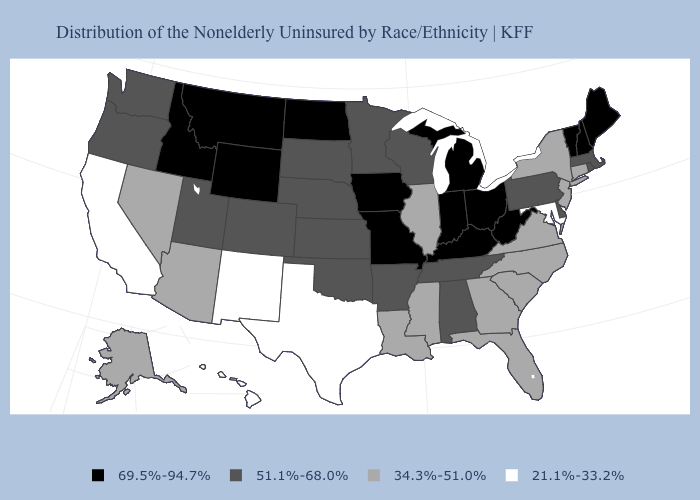What is the value of New York?
Short answer required. 34.3%-51.0%. Which states have the lowest value in the USA?
Answer briefly. California, Hawaii, Maryland, New Mexico, Texas. What is the highest value in the West ?
Short answer required. 69.5%-94.7%. Does Texas have the lowest value in the USA?
Write a very short answer. Yes. Is the legend a continuous bar?
Short answer required. No. Does Maryland have a lower value than Alaska?
Write a very short answer. Yes. What is the lowest value in states that border Virginia?
Answer briefly. 21.1%-33.2%. Name the states that have a value in the range 21.1%-33.2%?
Keep it brief. California, Hawaii, Maryland, New Mexico, Texas. Does the map have missing data?
Concise answer only. No. Name the states that have a value in the range 51.1%-68.0%?
Answer briefly. Alabama, Arkansas, Colorado, Delaware, Kansas, Massachusetts, Minnesota, Nebraska, Oklahoma, Oregon, Pennsylvania, Rhode Island, South Dakota, Tennessee, Utah, Washington, Wisconsin. Does South Dakota have the same value as Oregon?
Quick response, please. Yes. Among the states that border Oklahoma , does Kansas have the lowest value?
Concise answer only. No. Which states have the highest value in the USA?
Keep it brief. Idaho, Indiana, Iowa, Kentucky, Maine, Michigan, Missouri, Montana, New Hampshire, North Dakota, Ohio, Vermont, West Virginia, Wyoming. Name the states that have a value in the range 69.5%-94.7%?
Give a very brief answer. Idaho, Indiana, Iowa, Kentucky, Maine, Michigan, Missouri, Montana, New Hampshire, North Dakota, Ohio, Vermont, West Virginia, Wyoming. 